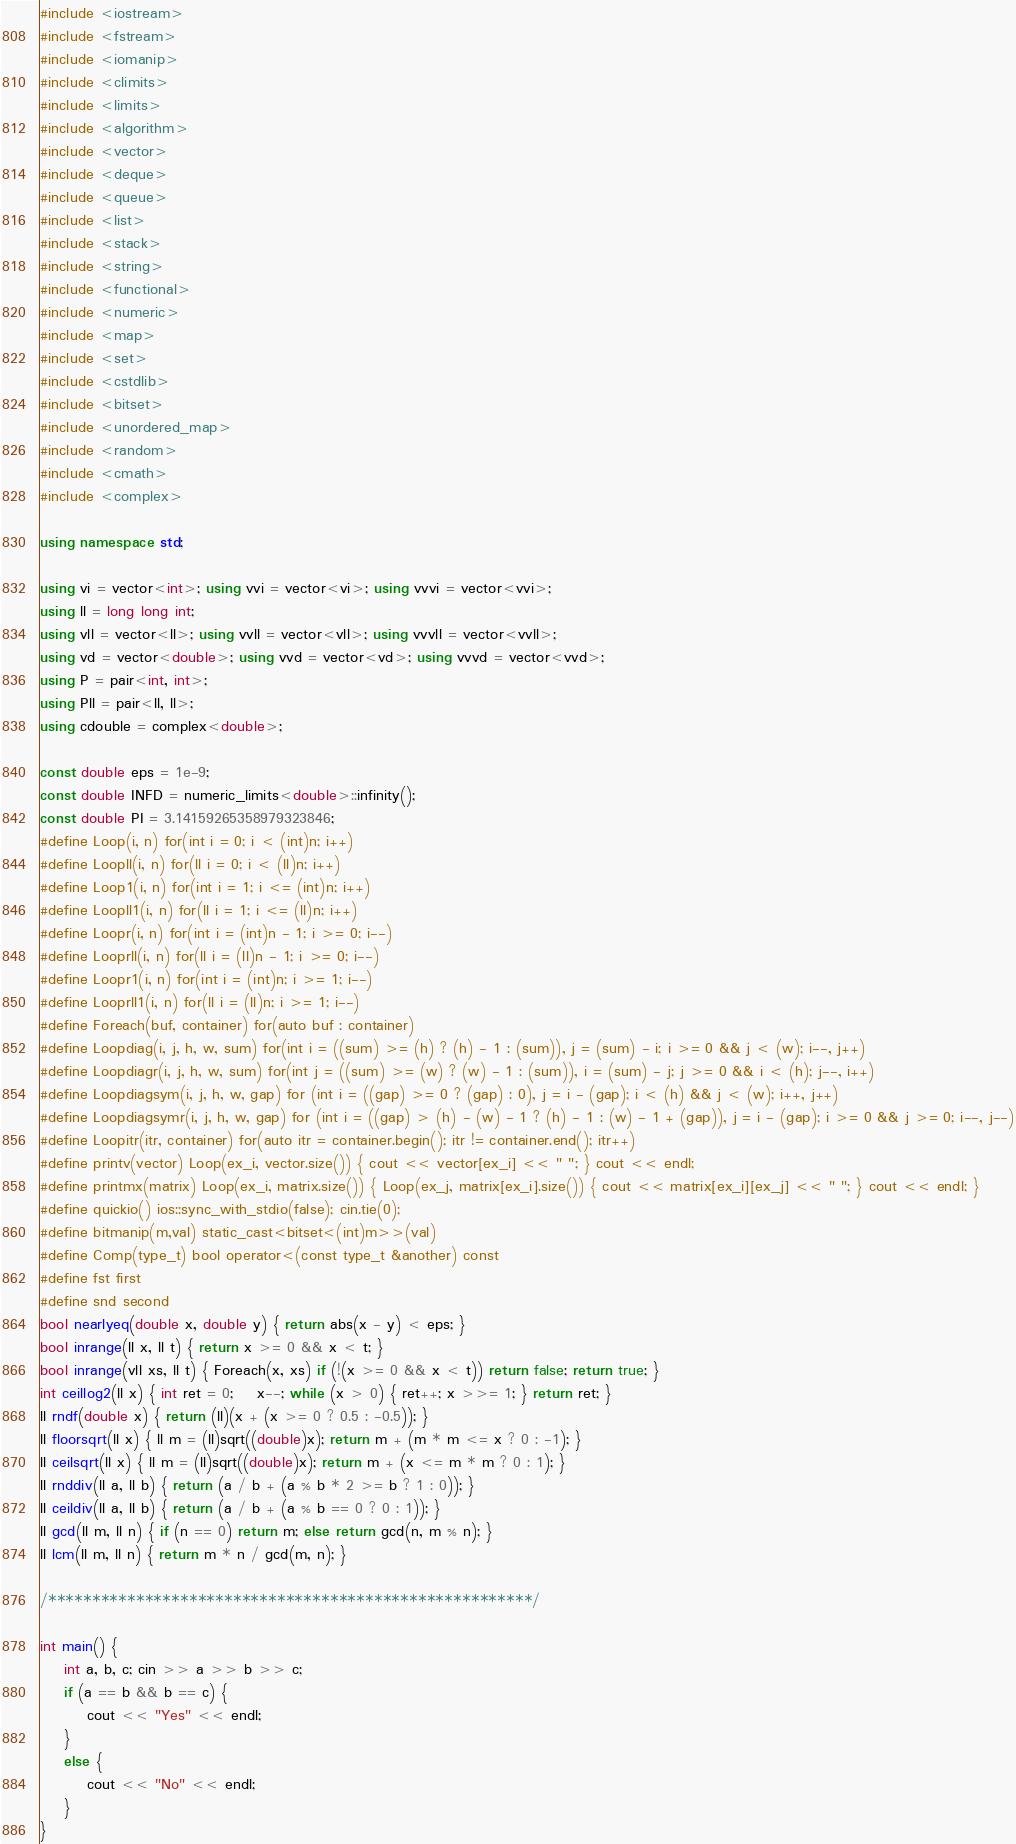Convert code to text. <code><loc_0><loc_0><loc_500><loc_500><_C++_>#include <iostream>
#include <fstream>
#include <iomanip>
#include <climits>
#include <limits>
#include <algorithm>
#include <vector>
#include <deque>
#include <queue>
#include <list>
#include <stack>
#include <string>
#include <functional>
#include <numeric>
#include <map>
#include <set>
#include <cstdlib>
#include <bitset>
#include <unordered_map>
#include <random>
#include <cmath>
#include <complex>

using namespace std;

using vi = vector<int>; using vvi = vector<vi>; using vvvi = vector<vvi>;
using ll = long long int;
using vll = vector<ll>; using vvll = vector<vll>; using vvvll = vector<vvll>;
using vd = vector<double>; using vvd = vector<vd>; using vvvd = vector<vvd>;
using P = pair<int, int>;
using Pll = pair<ll, ll>;
using cdouble = complex<double>;

const double eps = 1e-9;
const double INFD = numeric_limits<double>::infinity();
const double PI = 3.14159265358979323846;
#define Loop(i, n) for(int i = 0; i < (int)n; i++)
#define Loopll(i, n) for(ll i = 0; i < (ll)n; i++)
#define Loop1(i, n) for(int i = 1; i <= (int)n; i++)
#define Loopll1(i, n) for(ll i = 1; i <= (ll)n; i++)
#define Loopr(i, n) for(int i = (int)n - 1; i >= 0; i--)
#define Looprll(i, n) for(ll i = (ll)n - 1; i >= 0; i--)
#define Loopr1(i, n) for(int i = (int)n; i >= 1; i--)
#define Looprll1(i, n) for(ll i = (ll)n; i >= 1; i--)
#define Foreach(buf, container) for(auto buf : container)
#define Loopdiag(i, j, h, w, sum) for(int i = ((sum) >= (h) ? (h) - 1 : (sum)), j = (sum) - i; i >= 0 && j < (w); i--, j++)
#define Loopdiagr(i, j, h, w, sum) for(int j = ((sum) >= (w) ? (w) - 1 : (sum)), i = (sum) - j; j >= 0 && i < (h); j--, i++)
#define Loopdiagsym(i, j, h, w, gap) for (int i = ((gap) >= 0 ? (gap) : 0), j = i - (gap); i < (h) && j < (w); i++, j++)
#define Loopdiagsymr(i, j, h, w, gap) for (int i = ((gap) > (h) - (w) - 1 ? (h) - 1 : (w) - 1 + (gap)), j = i - (gap); i >= 0 && j >= 0; i--, j--)
#define Loopitr(itr, container) for(auto itr = container.begin(); itr != container.end(); itr++)
#define printv(vector) Loop(ex_i, vector.size()) { cout << vector[ex_i] << " "; } cout << endl;
#define printmx(matrix) Loop(ex_i, matrix.size()) { Loop(ex_j, matrix[ex_i].size()) { cout << matrix[ex_i][ex_j] << " "; } cout << endl; }
#define quickio() ios::sync_with_stdio(false); cin.tie(0);
#define bitmanip(m,val) static_cast<bitset<(int)m>>(val)
#define Comp(type_t) bool operator<(const type_t &another) const
#define fst first
#define snd second
bool nearlyeq(double x, double y) { return abs(x - y) < eps; }
bool inrange(ll x, ll t) { return x >= 0 && x < t; }
bool inrange(vll xs, ll t) { Foreach(x, xs) if (!(x >= 0 && x < t)) return false; return true; }
int ceillog2(ll x) { int ret = 0;	x--; while (x > 0) { ret++; x >>= 1; } return ret; }
ll rndf(double x) { return (ll)(x + (x >= 0 ? 0.5 : -0.5)); }
ll floorsqrt(ll x) { ll m = (ll)sqrt((double)x); return m + (m * m <= x ? 0 : -1); }
ll ceilsqrt(ll x) { ll m = (ll)sqrt((double)x); return m + (x <= m * m ? 0 : 1); }
ll rnddiv(ll a, ll b) { return (a / b + (a % b * 2 >= b ? 1 : 0)); }
ll ceildiv(ll a, ll b) { return (a / b + (a % b == 0 ? 0 : 1)); }
ll gcd(ll m, ll n) { if (n == 0) return m; else return gcd(n, m % n); }
ll lcm(ll m, ll n) { return m * n / gcd(m, n); }

/*******************************************************/

int main() {
	int a, b, c; cin >> a >> b >> c;
	if (a == b && b == c) {
		cout << "Yes" << endl;
	}
	else {
		cout << "No" << endl;
	}
}</code> 